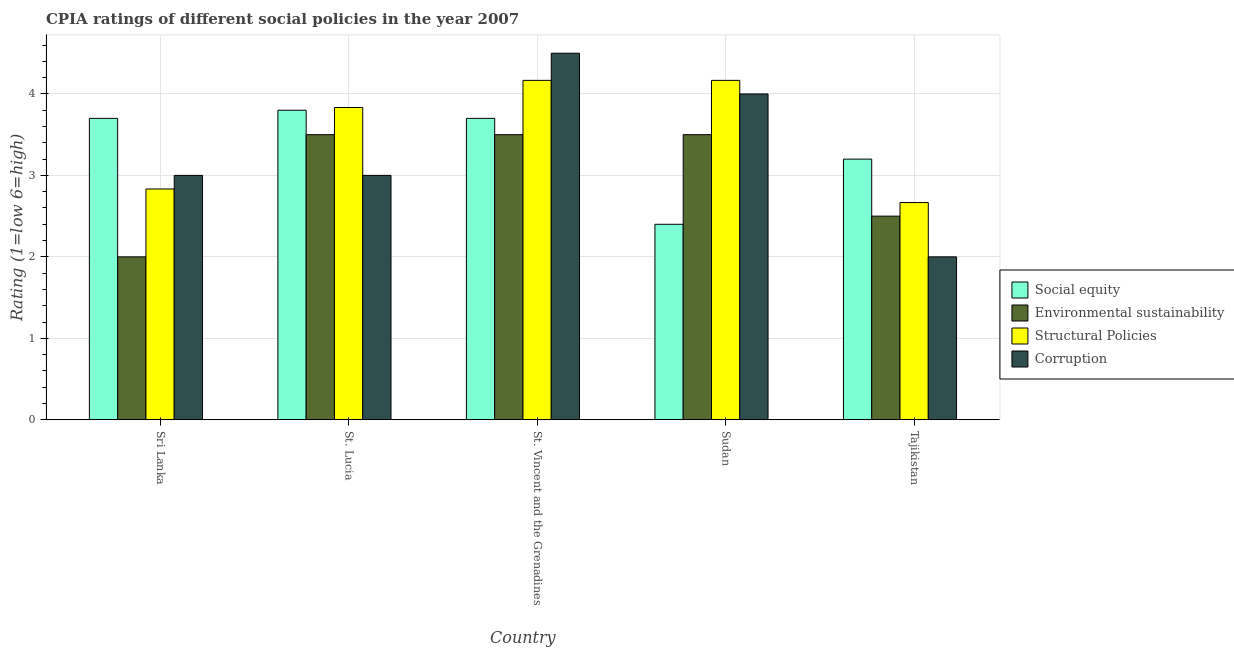How many different coloured bars are there?
Make the answer very short. 4. How many groups of bars are there?
Give a very brief answer. 5. How many bars are there on the 5th tick from the right?
Your answer should be very brief. 4. What is the label of the 1st group of bars from the left?
Keep it short and to the point. Sri Lanka. In how many cases, is the number of bars for a given country not equal to the number of legend labels?
Offer a terse response. 0. Across all countries, what is the maximum cpia rating of structural policies?
Offer a terse response. 4.17. Across all countries, what is the minimum cpia rating of social equity?
Offer a very short reply. 2.4. In which country was the cpia rating of structural policies maximum?
Your response must be concise. St. Vincent and the Grenadines. In which country was the cpia rating of social equity minimum?
Ensure brevity in your answer.  Sudan. What is the total cpia rating of structural policies in the graph?
Provide a short and direct response. 17.67. What is the difference between the cpia rating of social equity in Sudan and that in Tajikistan?
Give a very brief answer. -0.8. What is the difference between the cpia rating of environmental sustainability in St. Vincent and the Grenadines and the cpia rating of structural policies in Tajikistan?
Keep it short and to the point. 0.83. What is the average cpia rating of corruption per country?
Offer a very short reply. 3.3. What is the difference between the cpia rating of environmental sustainability and cpia rating of structural policies in Sudan?
Your response must be concise. -0.67. Is the difference between the cpia rating of structural policies in Sri Lanka and Sudan greater than the difference between the cpia rating of environmental sustainability in Sri Lanka and Sudan?
Provide a succinct answer. Yes. What is the difference between the highest and the second highest cpia rating of structural policies?
Keep it short and to the point. 0. In how many countries, is the cpia rating of structural policies greater than the average cpia rating of structural policies taken over all countries?
Give a very brief answer. 3. Is the sum of the cpia rating of corruption in St. Lucia and Tajikistan greater than the maximum cpia rating of environmental sustainability across all countries?
Provide a short and direct response. Yes. Is it the case that in every country, the sum of the cpia rating of structural policies and cpia rating of social equity is greater than the sum of cpia rating of environmental sustainability and cpia rating of corruption?
Ensure brevity in your answer.  Yes. What does the 4th bar from the left in Tajikistan represents?
Offer a terse response. Corruption. What does the 3rd bar from the right in Sudan represents?
Your response must be concise. Environmental sustainability. Is it the case that in every country, the sum of the cpia rating of social equity and cpia rating of environmental sustainability is greater than the cpia rating of structural policies?
Offer a terse response. Yes. How many bars are there?
Keep it short and to the point. 20. How many countries are there in the graph?
Ensure brevity in your answer.  5. What is the difference between two consecutive major ticks on the Y-axis?
Make the answer very short. 1. Does the graph contain any zero values?
Provide a succinct answer. No. How are the legend labels stacked?
Give a very brief answer. Vertical. What is the title of the graph?
Provide a succinct answer. CPIA ratings of different social policies in the year 2007. What is the label or title of the X-axis?
Your answer should be compact. Country. What is the label or title of the Y-axis?
Your response must be concise. Rating (1=low 6=high). What is the Rating (1=low 6=high) in Structural Policies in Sri Lanka?
Offer a very short reply. 2.83. What is the Rating (1=low 6=high) of Social equity in St. Lucia?
Your answer should be compact. 3.8. What is the Rating (1=low 6=high) in Structural Policies in St. Lucia?
Offer a terse response. 3.83. What is the Rating (1=low 6=high) in Corruption in St. Lucia?
Offer a terse response. 3. What is the Rating (1=low 6=high) in Environmental sustainability in St. Vincent and the Grenadines?
Provide a succinct answer. 3.5. What is the Rating (1=low 6=high) in Structural Policies in St. Vincent and the Grenadines?
Your response must be concise. 4.17. What is the Rating (1=low 6=high) in Social equity in Sudan?
Your answer should be very brief. 2.4. What is the Rating (1=low 6=high) of Environmental sustainability in Sudan?
Ensure brevity in your answer.  3.5. What is the Rating (1=low 6=high) of Structural Policies in Sudan?
Your answer should be compact. 4.17. What is the Rating (1=low 6=high) of Environmental sustainability in Tajikistan?
Ensure brevity in your answer.  2.5. What is the Rating (1=low 6=high) in Structural Policies in Tajikistan?
Your response must be concise. 2.67. Across all countries, what is the maximum Rating (1=low 6=high) in Social equity?
Your answer should be compact. 3.8. Across all countries, what is the maximum Rating (1=low 6=high) in Environmental sustainability?
Ensure brevity in your answer.  3.5. Across all countries, what is the maximum Rating (1=low 6=high) in Structural Policies?
Keep it short and to the point. 4.17. Across all countries, what is the minimum Rating (1=low 6=high) in Structural Policies?
Your answer should be compact. 2.67. What is the total Rating (1=low 6=high) of Structural Policies in the graph?
Offer a very short reply. 17.67. What is the total Rating (1=low 6=high) of Corruption in the graph?
Make the answer very short. 16.5. What is the difference between the Rating (1=low 6=high) in Environmental sustainability in Sri Lanka and that in St. Lucia?
Your answer should be very brief. -1.5. What is the difference between the Rating (1=low 6=high) in Corruption in Sri Lanka and that in St. Lucia?
Provide a succinct answer. 0. What is the difference between the Rating (1=low 6=high) in Environmental sustainability in Sri Lanka and that in St. Vincent and the Grenadines?
Give a very brief answer. -1.5. What is the difference between the Rating (1=low 6=high) of Structural Policies in Sri Lanka and that in St. Vincent and the Grenadines?
Offer a very short reply. -1.33. What is the difference between the Rating (1=low 6=high) in Corruption in Sri Lanka and that in St. Vincent and the Grenadines?
Keep it short and to the point. -1.5. What is the difference between the Rating (1=low 6=high) of Social equity in Sri Lanka and that in Sudan?
Make the answer very short. 1.3. What is the difference between the Rating (1=low 6=high) of Environmental sustainability in Sri Lanka and that in Sudan?
Offer a terse response. -1.5. What is the difference between the Rating (1=low 6=high) in Structural Policies in Sri Lanka and that in Sudan?
Your answer should be very brief. -1.33. What is the difference between the Rating (1=low 6=high) in Environmental sustainability in Sri Lanka and that in Tajikistan?
Give a very brief answer. -0.5. What is the difference between the Rating (1=low 6=high) in Structural Policies in Sri Lanka and that in Tajikistan?
Provide a short and direct response. 0.17. What is the difference between the Rating (1=low 6=high) of Corruption in Sri Lanka and that in Tajikistan?
Ensure brevity in your answer.  1. What is the difference between the Rating (1=low 6=high) of Social equity in St. Lucia and that in St. Vincent and the Grenadines?
Offer a very short reply. 0.1. What is the difference between the Rating (1=low 6=high) in Structural Policies in St. Lucia and that in St. Vincent and the Grenadines?
Make the answer very short. -0.33. What is the difference between the Rating (1=low 6=high) in Corruption in St. Lucia and that in St. Vincent and the Grenadines?
Keep it short and to the point. -1.5. What is the difference between the Rating (1=low 6=high) in Structural Policies in St. Lucia and that in Sudan?
Your answer should be very brief. -0.33. What is the difference between the Rating (1=low 6=high) in Social equity in St. Lucia and that in Tajikistan?
Give a very brief answer. 0.6. What is the difference between the Rating (1=low 6=high) in Structural Policies in St. Lucia and that in Tajikistan?
Provide a succinct answer. 1.17. What is the difference between the Rating (1=low 6=high) in Corruption in St. Lucia and that in Tajikistan?
Offer a very short reply. 1. What is the difference between the Rating (1=low 6=high) in Structural Policies in St. Vincent and the Grenadines and that in Sudan?
Offer a terse response. 0. What is the difference between the Rating (1=low 6=high) in Environmental sustainability in St. Vincent and the Grenadines and that in Tajikistan?
Give a very brief answer. 1. What is the difference between the Rating (1=low 6=high) of Structural Policies in St. Vincent and the Grenadines and that in Tajikistan?
Your response must be concise. 1.5. What is the difference between the Rating (1=low 6=high) in Corruption in St. Vincent and the Grenadines and that in Tajikistan?
Your answer should be very brief. 2.5. What is the difference between the Rating (1=low 6=high) in Social equity in Sudan and that in Tajikistan?
Your response must be concise. -0.8. What is the difference between the Rating (1=low 6=high) in Structural Policies in Sudan and that in Tajikistan?
Give a very brief answer. 1.5. What is the difference between the Rating (1=low 6=high) in Social equity in Sri Lanka and the Rating (1=low 6=high) in Environmental sustainability in St. Lucia?
Ensure brevity in your answer.  0.2. What is the difference between the Rating (1=low 6=high) in Social equity in Sri Lanka and the Rating (1=low 6=high) in Structural Policies in St. Lucia?
Your response must be concise. -0.13. What is the difference between the Rating (1=low 6=high) of Social equity in Sri Lanka and the Rating (1=low 6=high) of Corruption in St. Lucia?
Your answer should be very brief. 0.7. What is the difference between the Rating (1=low 6=high) in Environmental sustainability in Sri Lanka and the Rating (1=low 6=high) in Structural Policies in St. Lucia?
Offer a very short reply. -1.83. What is the difference between the Rating (1=low 6=high) of Environmental sustainability in Sri Lanka and the Rating (1=low 6=high) of Corruption in St. Lucia?
Offer a very short reply. -1. What is the difference between the Rating (1=low 6=high) of Structural Policies in Sri Lanka and the Rating (1=low 6=high) of Corruption in St. Lucia?
Your answer should be compact. -0.17. What is the difference between the Rating (1=low 6=high) of Social equity in Sri Lanka and the Rating (1=low 6=high) of Structural Policies in St. Vincent and the Grenadines?
Keep it short and to the point. -0.47. What is the difference between the Rating (1=low 6=high) in Social equity in Sri Lanka and the Rating (1=low 6=high) in Corruption in St. Vincent and the Grenadines?
Keep it short and to the point. -0.8. What is the difference between the Rating (1=low 6=high) in Environmental sustainability in Sri Lanka and the Rating (1=low 6=high) in Structural Policies in St. Vincent and the Grenadines?
Ensure brevity in your answer.  -2.17. What is the difference between the Rating (1=low 6=high) in Structural Policies in Sri Lanka and the Rating (1=low 6=high) in Corruption in St. Vincent and the Grenadines?
Keep it short and to the point. -1.67. What is the difference between the Rating (1=low 6=high) of Social equity in Sri Lanka and the Rating (1=low 6=high) of Environmental sustainability in Sudan?
Keep it short and to the point. 0.2. What is the difference between the Rating (1=low 6=high) of Social equity in Sri Lanka and the Rating (1=low 6=high) of Structural Policies in Sudan?
Offer a terse response. -0.47. What is the difference between the Rating (1=low 6=high) in Environmental sustainability in Sri Lanka and the Rating (1=low 6=high) in Structural Policies in Sudan?
Give a very brief answer. -2.17. What is the difference between the Rating (1=low 6=high) of Environmental sustainability in Sri Lanka and the Rating (1=low 6=high) of Corruption in Sudan?
Your response must be concise. -2. What is the difference between the Rating (1=low 6=high) of Structural Policies in Sri Lanka and the Rating (1=low 6=high) of Corruption in Sudan?
Provide a short and direct response. -1.17. What is the difference between the Rating (1=low 6=high) in Social equity in Sri Lanka and the Rating (1=low 6=high) in Environmental sustainability in Tajikistan?
Your answer should be very brief. 1.2. What is the difference between the Rating (1=low 6=high) of Social equity in Sri Lanka and the Rating (1=low 6=high) of Corruption in Tajikistan?
Provide a succinct answer. 1.7. What is the difference between the Rating (1=low 6=high) of Environmental sustainability in Sri Lanka and the Rating (1=low 6=high) of Corruption in Tajikistan?
Offer a terse response. 0. What is the difference between the Rating (1=low 6=high) of Structural Policies in Sri Lanka and the Rating (1=low 6=high) of Corruption in Tajikistan?
Provide a short and direct response. 0.83. What is the difference between the Rating (1=low 6=high) in Social equity in St. Lucia and the Rating (1=low 6=high) in Environmental sustainability in St. Vincent and the Grenadines?
Provide a short and direct response. 0.3. What is the difference between the Rating (1=low 6=high) of Social equity in St. Lucia and the Rating (1=low 6=high) of Structural Policies in St. Vincent and the Grenadines?
Your response must be concise. -0.37. What is the difference between the Rating (1=low 6=high) in Social equity in St. Lucia and the Rating (1=low 6=high) in Corruption in St. Vincent and the Grenadines?
Provide a succinct answer. -0.7. What is the difference between the Rating (1=low 6=high) of Environmental sustainability in St. Lucia and the Rating (1=low 6=high) of Corruption in St. Vincent and the Grenadines?
Your answer should be compact. -1. What is the difference between the Rating (1=low 6=high) of Structural Policies in St. Lucia and the Rating (1=low 6=high) of Corruption in St. Vincent and the Grenadines?
Provide a succinct answer. -0.67. What is the difference between the Rating (1=low 6=high) in Social equity in St. Lucia and the Rating (1=low 6=high) in Environmental sustainability in Sudan?
Ensure brevity in your answer.  0.3. What is the difference between the Rating (1=low 6=high) of Social equity in St. Lucia and the Rating (1=low 6=high) of Structural Policies in Sudan?
Offer a very short reply. -0.37. What is the difference between the Rating (1=low 6=high) in Environmental sustainability in St. Lucia and the Rating (1=low 6=high) in Structural Policies in Sudan?
Give a very brief answer. -0.67. What is the difference between the Rating (1=low 6=high) of Structural Policies in St. Lucia and the Rating (1=low 6=high) of Corruption in Sudan?
Make the answer very short. -0.17. What is the difference between the Rating (1=low 6=high) of Social equity in St. Lucia and the Rating (1=low 6=high) of Structural Policies in Tajikistan?
Provide a succinct answer. 1.13. What is the difference between the Rating (1=low 6=high) of Structural Policies in St. Lucia and the Rating (1=low 6=high) of Corruption in Tajikistan?
Make the answer very short. 1.83. What is the difference between the Rating (1=low 6=high) of Social equity in St. Vincent and the Grenadines and the Rating (1=low 6=high) of Environmental sustainability in Sudan?
Provide a short and direct response. 0.2. What is the difference between the Rating (1=low 6=high) of Social equity in St. Vincent and the Grenadines and the Rating (1=low 6=high) of Structural Policies in Sudan?
Your answer should be compact. -0.47. What is the difference between the Rating (1=low 6=high) in Social equity in St. Vincent and the Grenadines and the Rating (1=low 6=high) in Corruption in Sudan?
Make the answer very short. -0.3. What is the difference between the Rating (1=low 6=high) of Environmental sustainability in St. Vincent and the Grenadines and the Rating (1=low 6=high) of Structural Policies in Sudan?
Offer a terse response. -0.67. What is the difference between the Rating (1=low 6=high) in Environmental sustainability in St. Vincent and the Grenadines and the Rating (1=low 6=high) in Corruption in Sudan?
Ensure brevity in your answer.  -0.5. What is the difference between the Rating (1=low 6=high) of Social equity in St. Vincent and the Grenadines and the Rating (1=low 6=high) of Structural Policies in Tajikistan?
Offer a terse response. 1.03. What is the difference between the Rating (1=low 6=high) in Environmental sustainability in St. Vincent and the Grenadines and the Rating (1=low 6=high) in Corruption in Tajikistan?
Provide a short and direct response. 1.5. What is the difference between the Rating (1=low 6=high) in Structural Policies in St. Vincent and the Grenadines and the Rating (1=low 6=high) in Corruption in Tajikistan?
Ensure brevity in your answer.  2.17. What is the difference between the Rating (1=low 6=high) of Social equity in Sudan and the Rating (1=low 6=high) of Environmental sustainability in Tajikistan?
Your answer should be compact. -0.1. What is the difference between the Rating (1=low 6=high) in Social equity in Sudan and the Rating (1=low 6=high) in Structural Policies in Tajikistan?
Your response must be concise. -0.27. What is the difference between the Rating (1=low 6=high) in Social equity in Sudan and the Rating (1=low 6=high) in Corruption in Tajikistan?
Offer a very short reply. 0.4. What is the difference between the Rating (1=low 6=high) in Structural Policies in Sudan and the Rating (1=low 6=high) in Corruption in Tajikistan?
Your answer should be compact. 2.17. What is the average Rating (1=low 6=high) of Social equity per country?
Provide a short and direct response. 3.36. What is the average Rating (1=low 6=high) in Environmental sustainability per country?
Your response must be concise. 3. What is the average Rating (1=low 6=high) in Structural Policies per country?
Make the answer very short. 3.53. What is the difference between the Rating (1=low 6=high) of Social equity and Rating (1=low 6=high) of Structural Policies in Sri Lanka?
Keep it short and to the point. 0.87. What is the difference between the Rating (1=low 6=high) of Environmental sustainability and Rating (1=low 6=high) of Structural Policies in Sri Lanka?
Your answer should be compact. -0.83. What is the difference between the Rating (1=low 6=high) of Structural Policies and Rating (1=low 6=high) of Corruption in Sri Lanka?
Keep it short and to the point. -0.17. What is the difference between the Rating (1=low 6=high) of Social equity and Rating (1=low 6=high) of Environmental sustainability in St. Lucia?
Provide a succinct answer. 0.3. What is the difference between the Rating (1=low 6=high) of Social equity and Rating (1=low 6=high) of Structural Policies in St. Lucia?
Give a very brief answer. -0.03. What is the difference between the Rating (1=low 6=high) in Environmental sustainability and Rating (1=low 6=high) in Structural Policies in St. Lucia?
Offer a terse response. -0.33. What is the difference between the Rating (1=low 6=high) in Environmental sustainability and Rating (1=low 6=high) in Corruption in St. Lucia?
Ensure brevity in your answer.  0.5. What is the difference between the Rating (1=low 6=high) of Social equity and Rating (1=low 6=high) of Environmental sustainability in St. Vincent and the Grenadines?
Your answer should be very brief. 0.2. What is the difference between the Rating (1=low 6=high) in Social equity and Rating (1=low 6=high) in Structural Policies in St. Vincent and the Grenadines?
Provide a succinct answer. -0.47. What is the difference between the Rating (1=low 6=high) of Social equity and Rating (1=low 6=high) of Corruption in St. Vincent and the Grenadines?
Make the answer very short. -0.8. What is the difference between the Rating (1=low 6=high) in Environmental sustainability and Rating (1=low 6=high) in Structural Policies in St. Vincent and the Grenadines?
Offer a very short reply. -0.67. What is the difference between the Rating (1=low 6=high) of Social equity and Rating (1=low 6=high) of Structural Policies in Sudan?
Give a very brief answer. -1.77. What is the difference between the Rating (1=low 6=high) in Social equity and Rating (1=low 6=high) in Environmental sustainability in Tajikistan?
Provide a short and direct response. 0.7. What is the difference between the Rating (1=low 6=high) in Social equity and Rating (1=low 6=high) in Structural Policies in Tajikistan?
Your response must be concise. 0.53. What is the difference between the Rating (1=low 6=high) in Social equity and Rating (1=low 6=high) in Corruption in Tajikistan?
Provide a short and direct response. 1.2. What is the difference between the Rating (1=low 6=high) in Environmental sustainability and Rating (1=low 6=high) in Corruption in Tajikistan?
Offer a terse response. 0.5. What is the difference between the Rating (1=low 6=high) in Structural Policies and Rating (1=low 6=high) in Corruption in Tajikistan?
Give a very brief answer. 0.67. What is the ratio of the Rating (1=low 6=high) in Social equity in Sri Lanka to that in St. Lucia?
Ensure brevity in your answer.  0.97. What is the ratio of the Rating (1=low 6=high) of Structural Policies in Sri Lanka to that in St. Lucia?
Provide a succinct answer. 0.74. What is the ratio of the Rating (1=low 6=high) in Social equity in Sri Lanka to that in St. Vincent and the Grenadines?
Your answer should be very brief. 1. What is the ratio of the Rating (1=low 6=high) in Structural Policies in Sri Lanka to that in St. Vincent and the Grenadines?
Ensure brevity in your answer.  0.68. What is the ratio of the Rating (1=low 6=high) in Corruption in Sri Lanka to that in St. Vincent and the Grenadines?
Your answer should be compact. 0.67. What is the ratio of the Rating (1=low 6=high) in Social equity in Sri Lanka to that in Sudan?
Your answer should be compact. 1.54. What is the ratio of the Rating (1=low 6=high) of Environmental sustainability in Sri Lanka to that in Sudan?
Give a very brief answer. 0.57. What is the ratio of the Rating (1=low 6=high) of Structural Policies in Sri Lanka to that in Sudan?
Keep it short and to the point. 0.68. What is the ratio of the Rating (1=low 6=high) in Social equity in Sri Lanka to that in Tajikistan?
Provide a succinct answer. 1.16. What is the ratio of the Rating (1=low 6=high) in Environmental sustainability in Sri Lanka to that in Tajikistan?
Offer a terse response. 0.8. What is the ratio of the Rating (1=low 6=high) in Corruption in Sri Lanka to that in Tajikistan?
Provide a short and direct response. 1.5. What is the ratio of the Rating (1=low 6=high) of Social equity in St. Lucia to that in Sudan?
Offer a terse response. 1.58. What is the ratio of the Rating (1=low 6=high) of Environmental sustainability in St. Lucia to that in Sudan?
Keep it short and to the point. 1. What is the ratio of the Rating (1=low 6=high) of Structural Policies in St. Lucia to that in Sudan?
Your answer should be very brief. 0.92. What is the ratio of the Rating (1=low 6=high) in Corruption in St. Lucia to that in Sudan?
Provide a succinct answer. 0.75. What is the ratio of the Rating (1=low 6=high) in Social equity in St. Lucia to that in Tajikistan?
Offer a very short reply. 1.19. What is the ratio of the Rating (1=low 6=high) of Environmental sustainability in St. Lucia to that in Tajikistan?
Your answer should be compact. 1.4. What is the ratio of the Rating (1=low 6=high) of Structural Policies in St. Lucia to that in Tajikistan?
Provide a succinct answer. 1.44. What is the ratio of the Rating (1=low 6=high) in Corruption in St. Lucia to that in Tajikistan?
Give a very brief answer. 1.5. What is the ratio of the Rating (1=low 6=high) in Social equity in St. Vincent and the Grenadines to that in Sudan?
Your response must be concise. 1.54. What is the ratio of the Rating (1=low 6=high) of Environmental sustainability in St. Vincent and the Grenadines to that in Sudan?
Give a very brief answer. 1. What is the ratio of the Rating (1=low 6=high) of Corruption in St. Vincent and the Grenadines to that in Sudan?
Provide a succinct answer. 1.12. What is the ratio of the Rating (1=low 6=high) of Social equity in St. Vincent and the Grenadines to that in Tajikistan?
Your answer should be very brief. 1.16. What is the ratio of the Rating (1=low 6=high) of Environmental sustainability in St. Vincent and the Grenadines to that in Tajikistan?
Your answer should be very brief. 1.4. What is the ratio of the Rating (1=low 6=high) in Structural Policies in St. Vincent and the Grenadines to that in Tajikistan?
Keep it short and to the point. 1.56. What is the ratio of the Rating (1=low 6=high) in Corruption in St. Vincent and the Grenadines to that in Tajikistan?
Keep it short and to the point. 2.25. What is the ratio of the Rating (1=low 6=high) in Structural Policies in Sudan to that in Tajikistan?
Offer a very short reply. 1.56. What is the difference between the highest and the second highest Rating (1=low 6=high) of Structural Policies?
Ensure brevity in your answer.  0. What is the difference between the highest and the second highest Rating (1=low 6=high) in Corruption?
Make the answer very short. 0.5. What is the difference between the highest and the lowest Rating (1=low 6=high) of Environmental sustainability?
Ensure brevity in your answer.  1.5. What is the difference between the highest and the lowest Rating (1=low 6=high) of Structural Policies?
Ensure brevity in your answer.  1.5. 